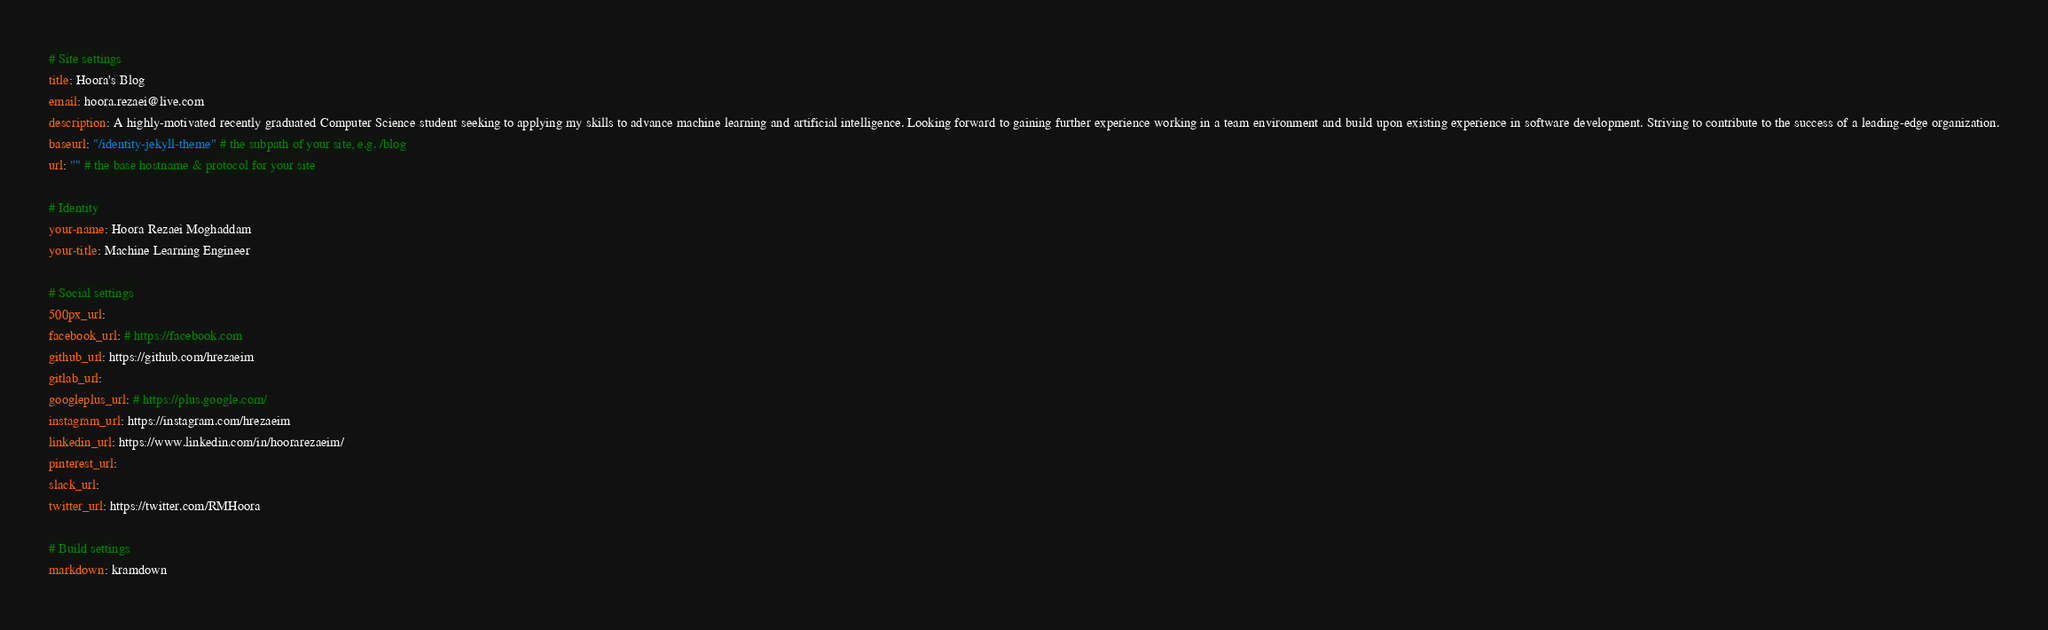Convert code to text. <code><loc_0><loc_0><loc_500><loc_500><_YAML_># Site settings
title: Hoora's Blog
email: hoora.rezaei@live.com
description: A highly-motivated recently graduated Computer Science student seeking to applying my skills to advance machine learning and artificial intelligence. Looking forward to gaining further experience working in a team environment and build upon existing experience in software development. Striving to contribute to the success of a leading-edge organization.
baseurl: "/identity-jekyll-theme" # the subpath of your site, e.g. /blog
url: "" # the base hostname & protocol for your site

# Identity
your-name: Hoora Rezaei Moghaddam
your-title: Machine Learning Engineer

# Social settings
500px_url:
facebook_url: # https://facebook.com
github_url: https://github.com/hrezaeim
gitlab_url: 
googleplus_url: # https://plus.google.com/
instagram_url: https://instagram.com/hrezaeim
linkedin_url: https://www.linkedin.com/in/hoorarezaeim/
pinterest_url:
slack_url:
twitter_url: https://twitter.com/RMHoora

# Build settings
markdown: kramdown
</code> 